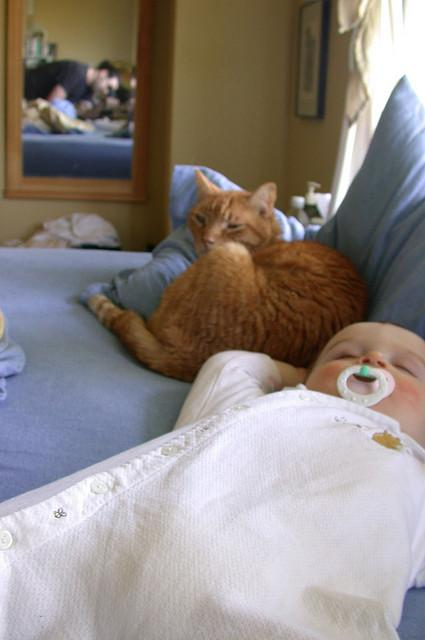How many different living creatures are visible here? Please explain your reasoning. three. There are a baby and cat on the bed, and a person taking the photo next to it. 